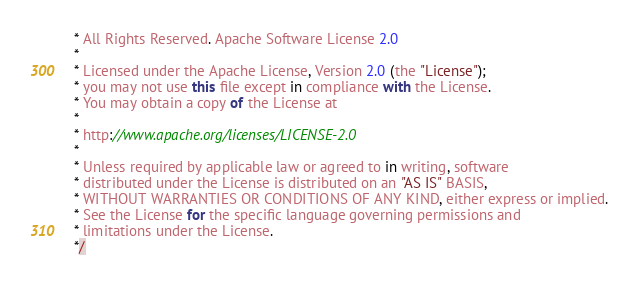<code> <loc_0><loc_0><loc_500><loc_500><_JavaScript_> * All Rights Reserved. Apache Software License 2.0
 *
 * Licensed under the Apache License, Version 2.0 (the "License");
 * you may not use this file except in compliance with the License.
 * You may obtain a copy of the License at
 *
 * http://www.apache.org/licenses/LICENSE-2.0
 *
 * Unless required by applicable law or agreed to in writing, software
 * distributed under the License is distributed on an "AS IS" BASIS,
 * WITHOUT WARRANTIES OR CONDITIONS OF ANY KIND, either express or implied.
 * See the License for the specific language governing permissions and
 * limitations under the License.
 */</code> 